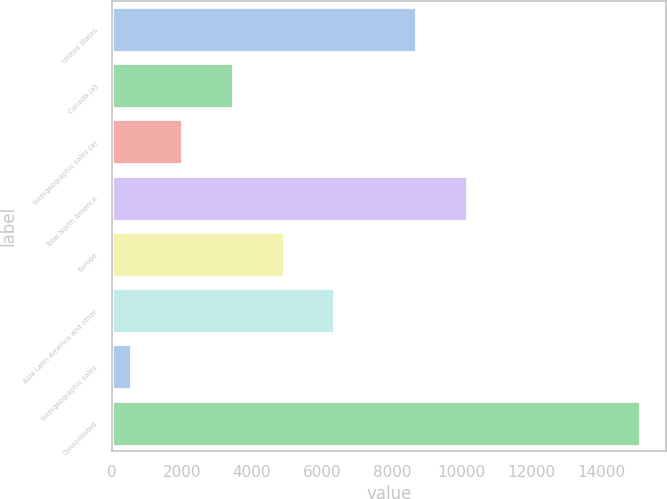<chart> <loc_0><loc_0><loc_500><loc_500><bar_chart><fcel>United States<fcel>Canada (a)<fcel>Intergeographic sales (a)<fcel>Total North America<fcel>Europe<fcel>Asia Latin America and other<fcel>Intergeographic sales<fcel>Consolidated<nl><fcel>8683.5<fcel>3451.84<fcel>1997.92<fcel>10137.4<fcel>4905.76<fcel>6359.68<fcel>544<fcel>15083.2<nl></chart> 